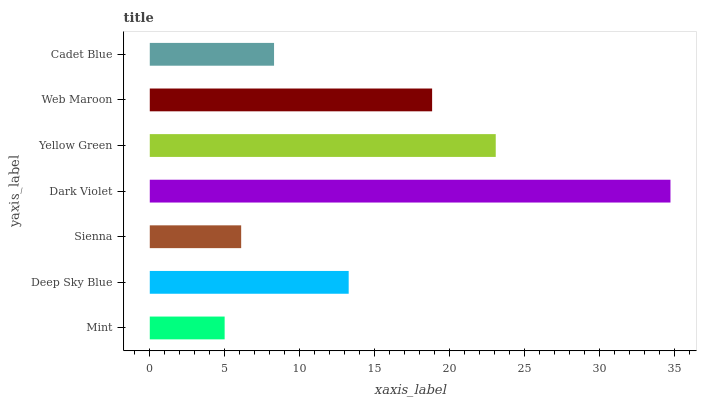Is Mint the minimum?
Answer yes or no. Yes. Is Dark Violet the maximum?
Answer yes or no. Yes. Is Deep Sky Blue the minimum?
Answer yes or no. No. Is Deep Sky Blue the maximum?
Answer yes or no. No. Is Deep Sky Blue greater than Mint?
Answer yes or no. Yes. Is Mint less than Deep Sky Blue?
Answer yes or no. Yes. Is Mint greater than Deep Sky Blue?
Answer yes or no. No. Is Deep Sky Blue less than Mint?
Answer yes or no. No. Is Deep Sky Blue the high median?
Answer yes or no. Yes. Is Deep Sky Blue the low median?
Answer yes or no. Yes. Is Web Maroon the high median?
Answer yes or no. No. Is Dark Violet the low median?
Answer yes or no. No. 